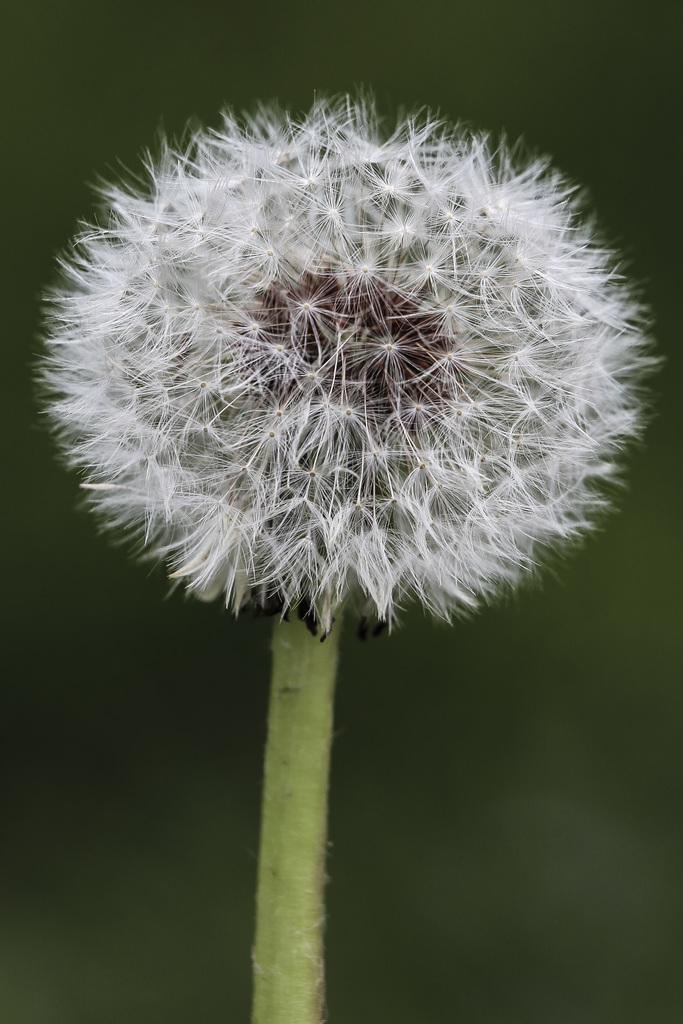What type of flower is in the image? There is a white color flower in the image. What is the color of the stem that the flower is on? The flower is on a green color stem. Can you describe the background of the image? The background of the image is blurred. What type of beef is being served in the image? There is no beef present in the image; it features a white color flower on a green color stem with a blurred background. 